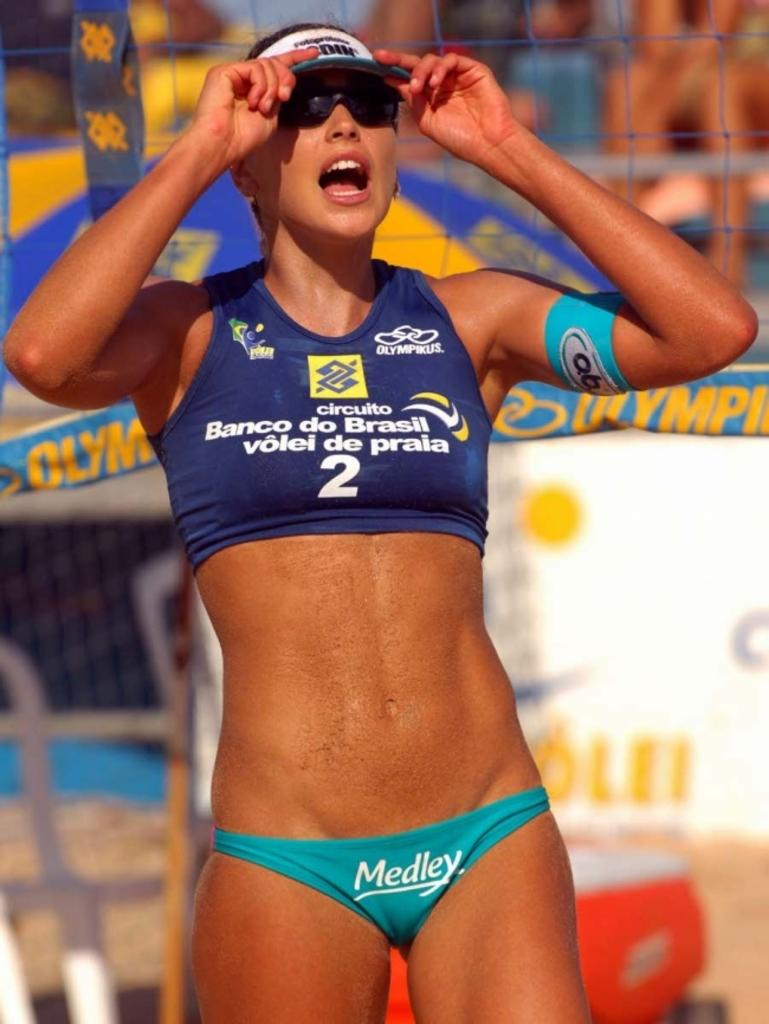<image>
Relay a brief, clear account of the picture shown. The bikini bottoms of an in-shape young woman have Medley on the front. 